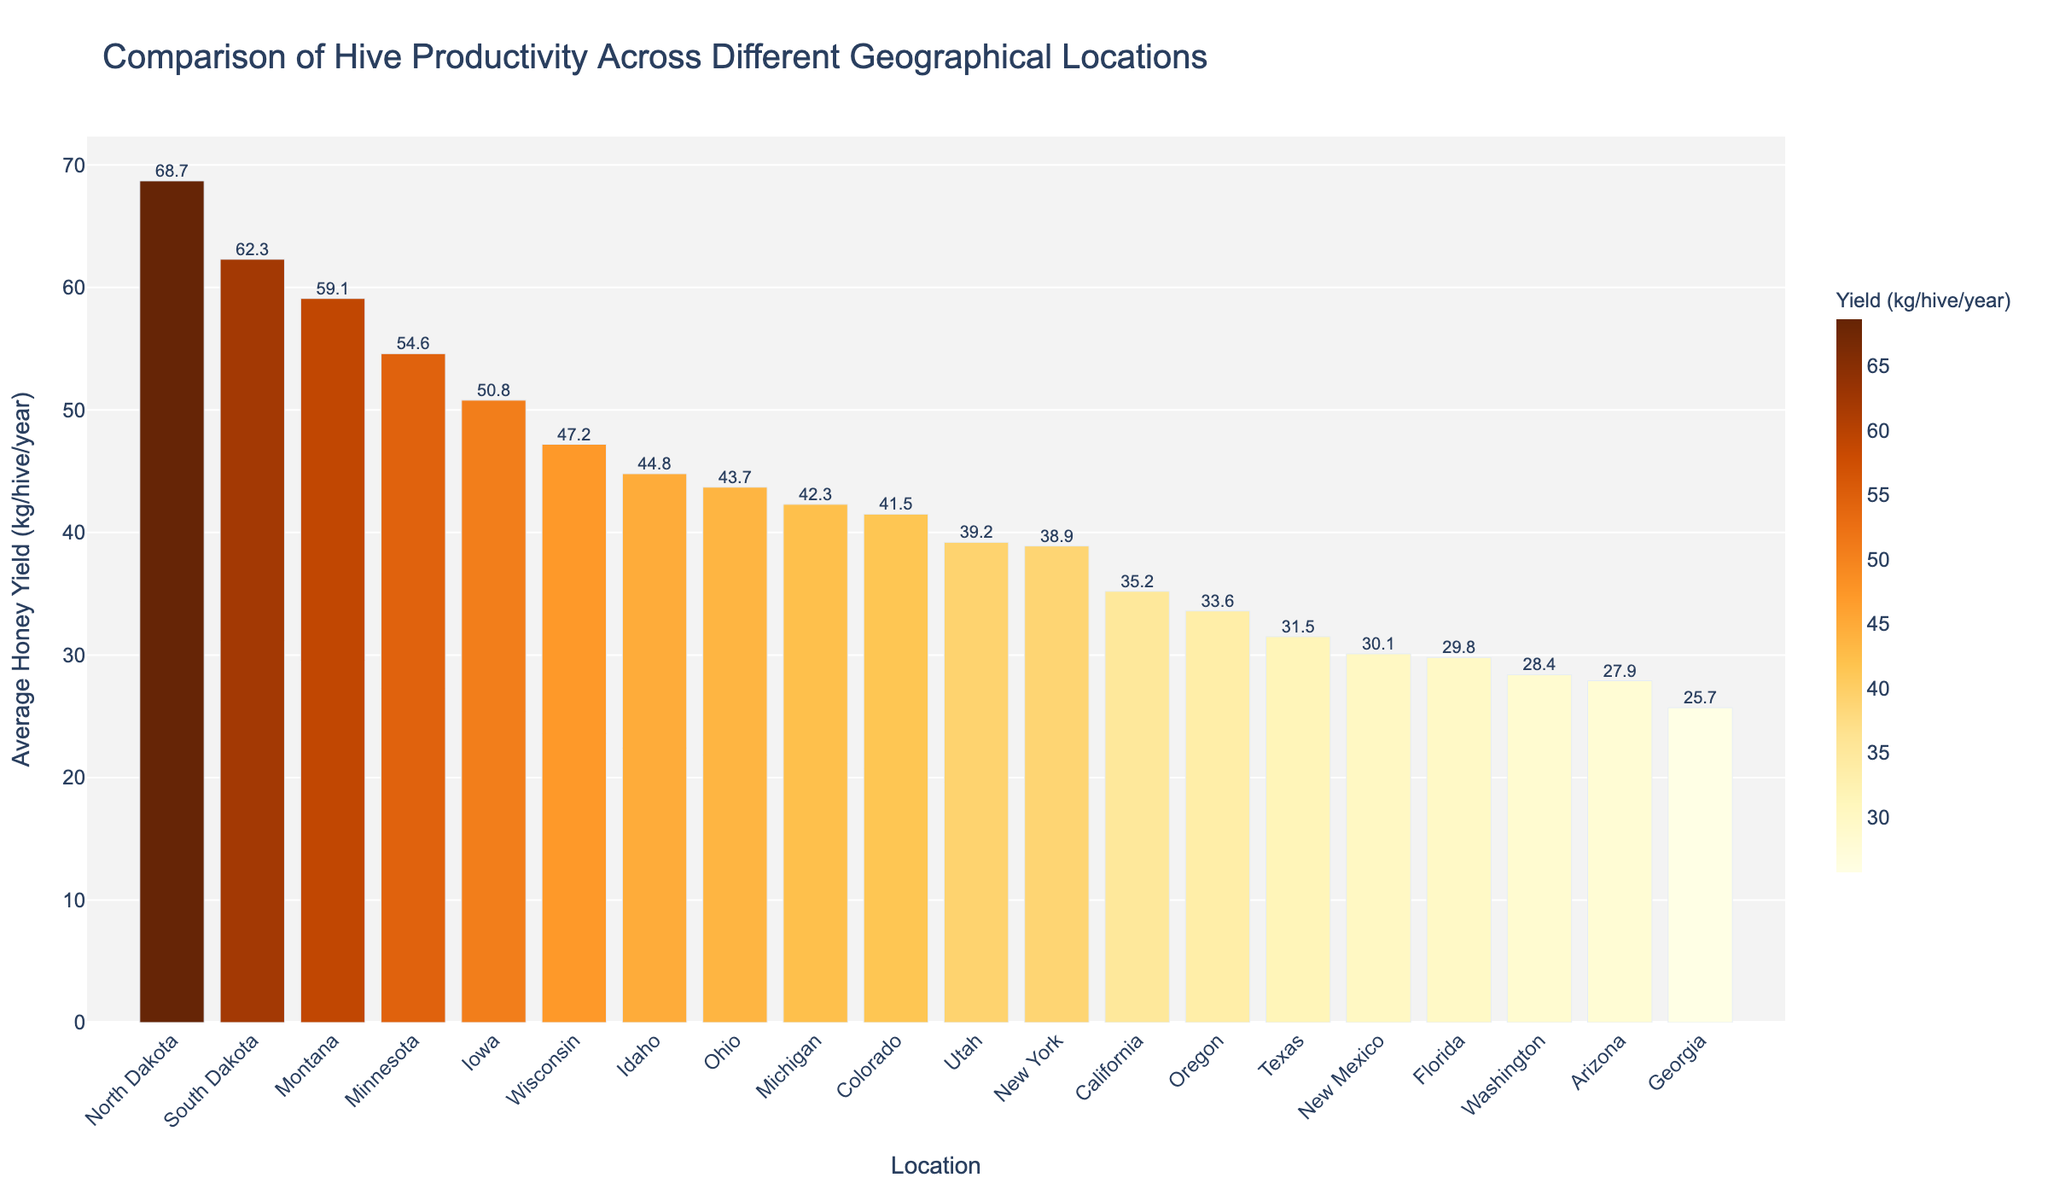Which location has the highest average honey yield? Locate the bar with the greatest height and label. North Dakota's bar is the tallest, showing the highest yield.
Answer: North Dakota How much more honey does North Dakota produce compared to Florida? Find the average yields for both locations from the labels on the bars. Subtract Florida's yield from North Dakota's yield (68.7 - 29.8).
Answer: 38.9 kg/hive/year What is the average honey yield for the top three productive locations? Identify the top three locations: North Dakota, South Dakota, and Montana. Sum their yields (68.7 + 62.3 + 59.1) and divide by 3.
Answer: 63.37 kg/hive/year Which geographical location has the lowest productivity? Find the bar with the smallest height and label. Georgia's bar is the shortest.
Answer: Georgia How does the honey yield of Texas compare to Oregon? Identify the bars for Texas and Oregon. Texas yields 31.5 kg/hive/year, while Oregon yields 33.6 kg/hive/year. Oregon’s yield is higher.
Answer: Oregon has a higher yield What is the combined honey yield of Ohio and Iowa? Find the average yields for Ohio and Iowa from the labels (43.7 and 50.8 respectively). Sum these values (43.7 + 50.8).
Answer: 94.5 kg/hive/year Which state has a yield closest to 40 kg/hive/year? Identify the bar closest to 40 kg on the y-axis. Utah has a yield of 39.2 kg/hive/year.
Answer: Utah Is the honey yield in Idaho higher or lower than Minnesota? Compare the bars for Idaho and Minnesota. Idaho yields 44.8 kg/hive/year and Minnesota yields 54.6 kg/hive/year. Idaho's yield is lower.
Answer: Lower How many geographical locations have an average yield greater than 50 kg/hive/year? Count the number of bars exceeding 50 kg/hive/year on the y-axis. The locations are North Dakota, South Dakota, Montana, Minnesota, Iowa.
Answer: 5 locations What is the total yield difference between South Dakota and Washington? Subtract the yield of Washington from South Dakota's yield (62.3 - 28.4).
Answer: 33.9 kg/hive/year 